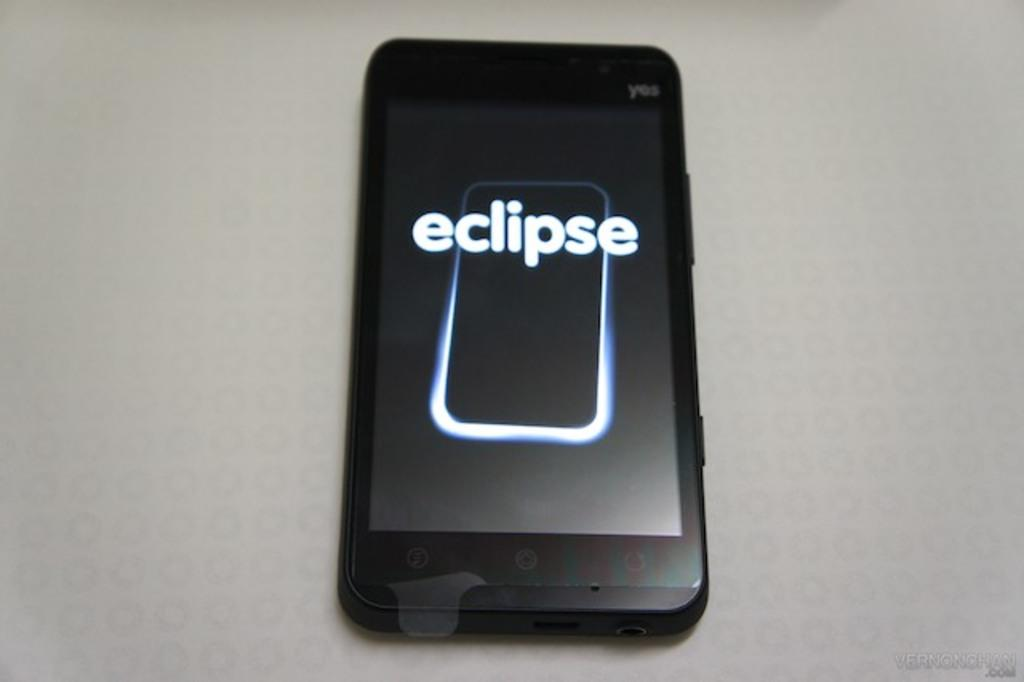<image>
Share a concise interpretation of the image provided. A smart phone with eclipse displayed on the screen. 